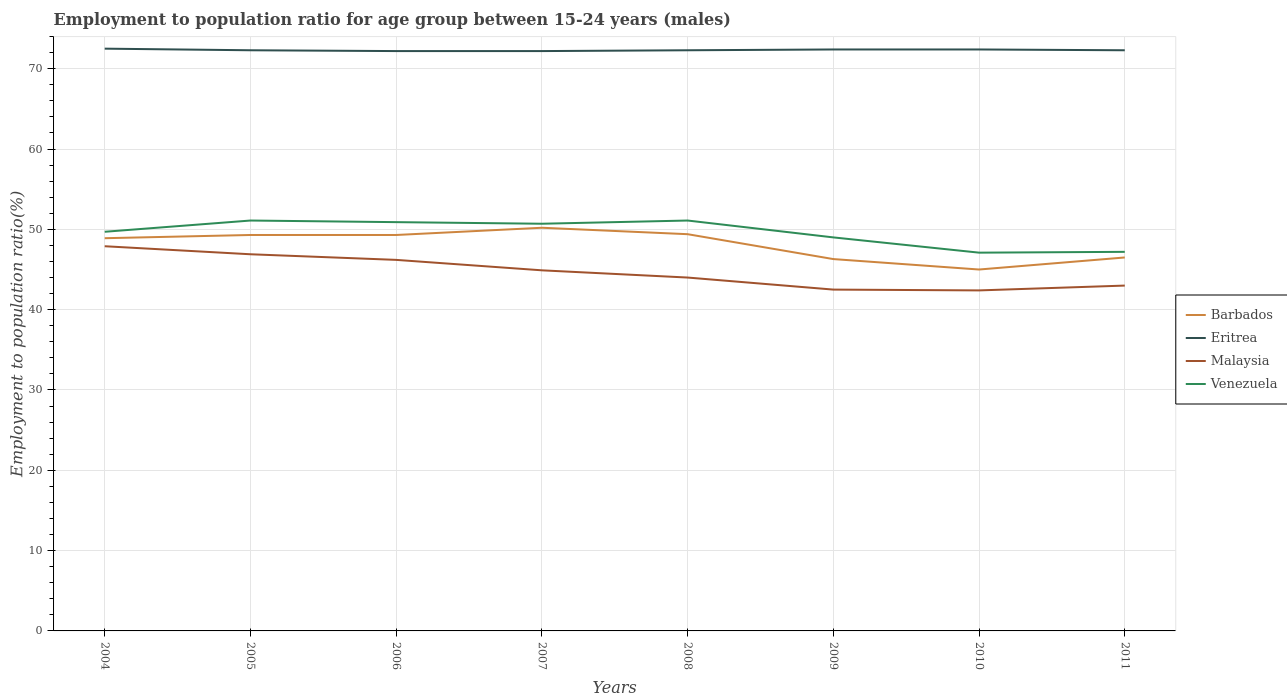Does the line corresponding to Eritrea intersect with the line corresponding to Barbados?
Provide a succinct answer. No. Is the number of lines equal to the number of legend labels?
Your response must be concise. Yes. Across all years, what is the maximum employment to population ratio in Malaysia?
Offer a terse response. 42.4. What is the total employment to population ratio in Eritrea in the graph?
Provide a short and direct response. 0.1. What is the difference between the highest and the second highest employment to population ratio in Barbados?
Your response must be concise. 5.2. What is the difference between the highest and the lowest employment to population ratio in Eritrea?
Offer a terse response. 3. Is the employment to population ratio in Barbados strictly greater than the employment to population ratio in Venezuela over the years?
Your response must be concise. Yes. How many lines are there?
Give a very brief answer. 4. How many years are there in the graph?
Your response must be concise. 8. What is the difference between two consecutive major ticks on the Y-axis?
Provide a succinct answer. 10. Does the graph contain grids?
Your answer should be compact. Yes. Where does the legend appear in the graph?
Your answer should be very brief. Center right. How are the legend labels stacked?
Give a very brief answer. Vertical. What is the title of the graph?
Make the answer very short. Employment to population ratio for age group between 15-24 years (males). What is the label or title of the X-axis?
Your answer should be compact. Years. What is the label or title of the Y-axis?
Offer a very short reply. Employment to population ratio(%). What is the Employment to population ratio(%) of Barbados in 2004?
Your answer should be very brief. 48.9. What is the Employment to population ratio(%) of Eritrea in 2004?
Provide a succinct answer. 72.5. What is the Employment to population ratio(%) in Malaysia in 2004?
Ensure brevity in your answer.  47.9. What is the Employment to population ratio(%) of Venezuela in 2004?
Provide a short and direct response. 49.7. What is the Employment to population ratio(%) of Barbados in 2005?
Offer a very short reply. 49.3. What is the Employment to population ratio(%) in Eritrea in 2005?
Give a very brief answer. 72.3. What is the Employment to population ratio(%) in Malaysia in 2005?
Give a very brief answer. 46.9. What is the Employment to population ratio(%) of Venezuela in 2005?
Your answer should be compact. 51.1. What is the Employment to population ratio(%) of Barbados in 2006?
Give a very brief answer. 49.3. What is the Employment to population ratio(%) of Eritrea in 2006?
Your answer should be very brief. 72.2. What is the Employment to population ratio(%) of Malaysia in 2006?
Give a very brief answer. 46.2. What is the Employment to population ratio(%) in Venezuela in 2006?
Your answer should be compact. 50.9. What is the Employment to population ratio(%) in Barbados in 2007?
Your answer should be very brief. 50.2. What is the Employment to population ratio(%) of Eritrea in 2007?
Make the answer very short. 72.2. What is the Employment to population ratio(%) of Malaysia in 2007?
Provide a short and direct response. 44.9. What is the Employment to population ratio(%) in Venezuela in 2007?
Provide a succinct answer. 50.7. What is the Employment to population ratio(%) in Barbados in 2008?
Offer a very short reply. 49.4. What is the Employment to population ratio(%) in Eritrea in 2008?
Give a very brief answer. 72.3. What is the Employment to population ratio(%) of Malaysia in 2008?
Offer a very short reply. 44. What is the Employment to population ratio(%) in Venezuela in 2008?
Provide a succinct answer. 51.1. What is the Employment to population ratio(%) of Barbados in 2009?
Make the answer very short. 46.3. What is the Employment to population ratio(%) of Eritrea in 2009?
Ensure brevity in your answer.  72.4. What is the Employment to population ratio(%) of Malaysia in 2009?
Provide a short and direct response. 42.5. What is the Employment to population ratio(%) in Barbados in 2010?
Offer a very short reply. 45. What is the Employment to population ratio(%) in Eritrea in 2010?
Offer a terse response. 72.4. What is the Employment to population ratio(%) in Malaysia in 2010?
Provide a short and direct response. 42.4. What is the Employment to population ratio(%) in Venezuela in 2010?
Make the answer very short. 47.1. What is the Employment to population ratio(%) of Barbados in 2011?
Offer a very short reply. 46.5. What is the Employment to population ratio(%) of Eritrea in 2011?
Make the answer very short. 72.3. What is the Employment to population ratio(%) in Venezuela in 2011?
Your answer should be very brief. 47.2. Across all years, what is the maximum Employment to population ratio(%) of Barbados?
Ensure brevity in your answer.  50.2. Across all years, what is the maximum Employment to population ratio(%) in Eritrea?
Provide a short and direct response. 72.5. Across all years, what is the maximum Employment to population ratio(%) of Malaysia?
Your answer should be very brief. 47.9. Across all years, what is the maximum Employment to population ratio(%) in Venezuela?
Make the answer very short. 51.1. Across all years, what is the minimum Employment to population ratio(%) of Eritrea?
Make the answer very short. 72.2. Across all years, what is the minimum Employment to population ratio(%) in Malaysia?
Provide a succinct answer. 42.4. Across all years, what is the minimum Employment to population ratio(%) of Venezuela?
Ensure brevity in your answer.  47.1. What is the total Employment to population ratio(%) in Barbados in the graph?
Provide a short and direct response. 384.9. What is the total Employment to population ratio(%) in Eritrea in the graph?
Make the answer very short. 578.6. What is the total Employment to population ratio(%) of Malaysia in the graph?
Keep it short and to the point. 357.8. What is the total Employment to population ratio(%) in Venezuela in the graph?
Keep it short and to the point. 396.8. What is the difference between the Employment to population ratio(%) of Barbados in 2004 and that in 2005?
Make the answer very short. -0.4. What is the difference between the Employment to population ratio(%) of Malaysia in 2004 and that in 2005?
Your answer should be compact. 1. What is the difference between the Employment to population ratio(%) of Eritrea in 2004 and that in 2006?
Provide a short and direct response. 0.3. What is the difference between the Employment to population ratio(%) in Malaysia in 2004 and that in 2006?
Your answer should be very brief. 1.7. What is the difference between the Employment to population ratio(%) in Barbados in 2004 and that in 2008?
Your response must be concise. -0.5. What is the difference between the Employment to population ratio(%) of Barbados in 2004 and that in 2009?
Ensure brevity in your answer.  2.6. What is the difference between the Employment to population ratio(%) in Venezuela in 2004 and that in 2009?
Give a very brief answer. 0.7. What is the difference between the Employment to population ratio(%) in Eritrea in 2004 and that in 2010?
Provide a succinct answer. 0.1. What is the difference between the Employment to population ratio(%) in Barbados in 2004 and that in 2011?
Provide a short and direct response. 2.4. What is the difference between the Employment to population ratio(%) in Eritrea in 2004 and that in 2011?
Your answer should be compact. 0.2. What is the difference between the Employment to population ratio(%) of Eritrea in 2005 and that in 2006?
Offer a terse response. 0.1. What is the difference between the Employment to population ratio(%) in Malaysia in 2005 and that in 2006?
Provide a succinct answer. 0.7. What is the difference between the Employment to population ratio(%) of Venezuela in 2005 and that in 2006?
Offer a very short reply. 0.2. What is the difference between the Employment to population ratio(%) in Barbados in 2005 and that in 2007?
Offer a terse response. -0.9. What is the difference between the Employment to population ratio(%) in Eritrea in 2005 and that in 2007?
Your answer should be compact. 0.1. What is the difference between the Employment to population ratio(%) in Malaysia in 2005 and that in 2007?
Give a very brief answer. 2. What is the difference between the Employment to population ratio(%) in Venezuela in 2005 and that in 2007?
Provide a short and direct response. 0.4. What is the difference between the Employment to population ratio(%) of Barbados in 2005 and that in 2008?
Make the answer very short. -0.1. What is the difference between the Employment to population ratio(%) in Eritrea in 2005 and that in 2008?
Your answer should be very brief. 0. What is the difference between the Employment to population ratio(%) of Malaysia in 2005 and that in 2008?
Keep it short and to the point. 2.9. What is the difference between the Employment to population ratio(%) in Barbados in 2005 and that in 2009?
Your answer should be very brief. 3. What is the difference between the Employment to population ratio(%) of Eritrea in 2005 and that in 2009?
Ensure brevity in your answer.  -0.1. What is the difference between the Employment to population ratio(%) of Malaysia in 2005 and that in 2009?
Your answer should be very brief. 4.4. What is the difference between the Employment to population ratio(%) in Barbados in 2005 and that in 2010?
Your answer should be very brief. 4.3. What is the difference between the Employment to population ratio(%) in Eritrea in 2005 and that in 2010?
Your answer should be very brief. -0.1. What is the difference between the Employment to population ratio(%) in Malaysia in 2005 and that in 2011?
Make the answer very short. 3.9. What is the difference between the Employment to population ratio(%) in Venezuela in 2005 and that in 2011?
Provide a succinct answer. 3.9. What is the difference between the Employment to population ratio(%) of Eritrea in 2006 and that in 2007?
Offer a terse response. 0. What is the difference between the Employment to population ratio(%) of Barbados in 2006 and that in 2008?
Your answer should be very brief. -0.1. What is the difference between the Employment to population ratio(%) in Venezuela in 2006 and that in 2008?
Your answer should be compact. -0.2. What is the difference between the Employment to population ratio(%) of Barbados in 2006 and that in 2009?
Make the answer very short. 3. What is the difference between the Employment to population ratio(%) in Malaysia in 2006 and that in 2009?
Ensure brevity in your answer.  3.7. What is the difference between the Employment to population ratio(%) in Barbados in 2006 and that in 2010?
Your answer should be very brief. 4.3. What is the difference between the Employment to population ratio(%) of Eritrea in 2006 and that in 2010?
Give a very brief answer. -0.2. What is the difference between the Employment to population ratio(%) in Malaysia in 2006 and that in 2010?
Make the answer very short. 3.8. What is the difference between the Employment to population ratio(%) in Venezuela in 2006 and that in 2010?
Give a very brief answer. 3.8. What is the difference between the Employment to population ratio(%) in Barbados in 2006 and that in 2011?
Your response must be concise. 2.8. What is the difference between the Employment to population ratio(%) in Eritrea in 2006 and that in 2011?
Your answer should be compact. -0.1. What is the difference between the Employment to population ratio(%) of Malaysia in 2006 and that in 2011?
Ensure brevity in your answer.  3.2. What is the difference between the Employment to population ratio(%) of Venezuela in 2006 and that in 2011?
Provide a short and direct response. 3.7. What is the difference between the Employment to population ratio(%) in Malaysia in 2007 and that in 2008?
Keep it short and to the point. 0.9. What is the difference between the Employment to population ratio(%) in Venezuela in 2007 and that in 2008?
Your answer should be very brief. -0.4. What is the difference between the Employment to population ratio(%) of Barbados in 2007 and that in 2009?
Offer a terse response. 3.9. What is the difference between the Employment to population ratio(%) in Malaysia in 2007 and that in 2009?
Offer a very short reply. 2.4. What is the difference between the Employment to population ratio(%) in Venezuela in 2007 and that in 2011?
Ensure brevity in your answer.  3.5. What is the difference between the Employment to population ratio(%) in Venezuela in 2008 and that in 2009?
Your answer should be compact. 2.1. What is the difference between the Employment to population ratio(%) in Barbados in 2008 and that in 2010?
Keep it short and to the point. 4.4. What is the difference between the Employment to population ratio(%) of Malaysia in 2008 and that in 2010?
Your answer should be compact. 1.6. What is the difference between the Employment to population ratio(%) of Venezuela in 2008 and that in 2010?
Your response must be concise. 4. What is the difference between the Employment to population ratio(%) in Barbados in 2008 and that in 2011?
Offer a very short reply. 2.9. What is the difference between the Employment to population ratio(%) in Eritrea in 2008 and that in 2011?
Make the answer very short. 0. What is the difference between the Employment to population ratio(%) of Barbados in 2009 and that in 2010?
Provide a succinct answer. 1.3. What is the difference between the Employment to population ratio(%) in Eritrea in 2009 and that in 2010?
Provide a short and direct response. 0. What is the difference between the Employment to population ratio(%) of Venezuela in 2009 and that in 2010?
Your answer should be very brief. 1.9. What is the difference between the Employment to population ratio(%) of Barbados in 2009 and that in 2011?
Your answer should be compact. -0.2. What is the difference between the Employment to population ratio(%) of Malaysia in 2009 and that in 2011?
Ensure brevity in your answer.  -0.5. What is the difference between the Employment to population ratio(%) of Venezuela in 2009 and that in 2011?
Your answer should be compact. 1.8. What is the difference between the Employment to population ratio(%) in Barbados in 2010 and that in 2011?
Make the answer very short. -1.5. What is the difference between the Employment to population ratio(%) in Venezuela in 2010 and that in 2011?
Provide a short and direct response. -0.1. What is the difference between the Employment to population ratio(%) in Barbados in 2004 and the Employment to population ratio(%) in Eritrea in 2005?
Keep it short and to the point. -23.4. What is the difference between the Employment to population ratio(%) in Barbados in 2004 and the Employment to population ratio(%) in Malaysia in 2005?
Your response must be concise. 2. What is the difference between the Employment to population ratio(%) of Eritrea in 2004 and the Employment to population ratio(%) of Malaysia in 2005?
Provide a short and direct response. 25.6. What is the difference between the Employment to population ratio(%) of Eritrea in 2004 and the Employment to population ratio(%) of Venezuela in 2005?
Your answer should be compact. 21.4. What is the difference between the Employment to population ratio(%) in Malaysia in 2004 and the Employment to population ratio(%) in Venezuela in 2005?
Give a very brief answer. -3.2. What is the difference between the Employment to population ratio(%) of Barbados in 2004 and the Employment to population ratio(%) of Eritrea in 2006?
Ensure brevity in your answer.  -23.3. What is the difference between the Employment to population ratio(%) of Barbados in 2004 and the Employment to population ratio(%) of Venezuela in 2006?
Make the answer very short. -2. What is the difference between the Employment to population ratio(%) of Eritrea in 2004 and the Employment to population ratio(%) of Malaysia in 2006?
Your answer should be very brief. 26.3. What is the difference between the Employment to population ratio(%) in Eritrea in 2004 and the Employment to population ratio(%) in Venezuela in 2006?
Make the answer very short. 21.6. What is the difference between the Employment to population ratio(%) in Barbados in 2004 and the Employment to population ratio(%) in Eritrea in 2007?
Your answer should be very brief. -23.3. What is the difference between the Employment to population ratio(%) in Eritrea in 2004 and the Employment to population ratio(%) in Malaysia in 2007?
Ensure brevity in your answer.  27.6. What is the difference between the Employment to population ratio(%) in Eritrea in 2004 and the Employment to population ratio(%) in Venezuela in 2007?
Ensure brevity in your answer.  21.8. What is the difference between the Employment to population ratio(%) of Barbados in 2004 and the Employment to population ratio(%) of Eritrea in 2008?
Ensure brevity in your answer.  -23.4. What is the difference between the Employment to population ratio(%) of Barbados in 2004 and the Employment to population ratio(%) of Venezuela in 2008?
Offer a terse response. -2.2. What is the difference between the Employment to population ratio(%) in Eritrea in 2004 and the Employment to population ratio(%) in Venezuela in 2008?
Offer a terse response. 21.4. What is the difference between the Employment to population ratio(%) of Barbados in 2004 and the Employment to population ratio(%) of Eritrea in 2009?
Provide a succinct answer. -23.5. What is the difference between the Employment to population ratio(%) of Barbados in 2004 and the Employment to population ratio(%) of Malaysia in 2009?
Offer a terse response. 6.4. What is the difference between the Employment to population ratio(%) in Eritrea in 2004 and the Employment to population ratio(%) in Malaysia in 2009?
Offer a very short reply. 30. What is the difference between the Employment to population ratio(%) in Malaysia in 2004 and the Employment to population ratio(%) in Venezuela in 2009?
Your answer should be compact. -1.1. What is the difference between the Employment to population ratio(%) in Barbados in 2004 and the Employment to population ratio(%) in Eritrea in 2010?
Make the answer very short. -23.5. What is the difference between the Employment to population ratio(%) in Barbados in 2004 and the Employment to population ratio(%) in Malaysia in 2010?
Your response must be concise. 6.5. What is the difference between the Employment to population ratio(%) in Eritrea in 2004 and the Employment to population ratio(%) in Malaysia in 2010?
Your answer should be compact. 30.1. What is the difference between the Employment to population ratio(%) of Eritrea in 2004 and the Employment to population ratio(%) of Venezuela in 2010?
Make the answer very short. 25.4. What is the difference between the Employment to population ratio(%) of Barbados in 2004 and the Employment to population ratio(%) of Eritrea in 2011?
Your response must be concise. -23.4. What is the difference between the Employment to population ratio(%) of Barbados in 2004 and the Employment to population ratio(%) of Malaysia in 2011?
Give a very brief answer. 5.9. What is the difference between the Employment to population ratio(%) of Eritrea in 2004 and the Employment to population ratio(%) of Malaysia in 2011?
Provide a succinct answer. 29.5. What is the difference between the Employment to population ratio(%) in Eritrea in 2004 and the Employment to population ratio(%) in Venezuela in 2011?
Your answer should be compact. 25.3. What is the difference between the Employment to population ratio(%) in Barbados in 2005 and the Employment to population ratio(%) in Eritrea in 2006?
Ensure brevity in your answer.  -22.9. What is the difference between the Employment to population ratio(%) of Barbados in 2005 and the Employment to population ratio(%) of Malaysia in 2006?
Provide a short and direct response. 3.1. What is the difference between the Employment to population ratio(%) of Eritrea in 2005 and the Employment to population ratio(%) of Malaysia in 2006?
Give a very brief answer. 26.1. What is the difference between the Employment to population ratio(%) in Eritrea in 2005 and the Employment to population ratio(%) in Venezuela in 2006?
Give a very brief answer. 21.4. What is the difference between the Employment to population ratio(%) in Barbados in 2005 and the Employment to population ratio(%) in Eritrea in 2007?
Ensure brevity in your answer.  -22.9. What is the difference between the Employment to population ratio(%) in Eritrea in 2005 and the Employment to population ratio(%) in Malaysia in 2007?
Ensure brevity in your answer.  27.4. What is the difference between the Employment to population ratio(%) in Eritrea in 2005 and the Employment to population ratio(%) in Venezuela in 2007?
Provide a succinct answer. 21.6. What is the difference between the Employment to population ratio(%) of Malaysia in 2005 and the Employment to population ratio(%) of Venezuela in 2007?
Your answer should be compact. -3.8. What is the difference between the Employment to population ratio(%) of Barbados in 2005 and the Employment to population ratio(%) of Eritrea in 2008?
Ensure brevity in your answer.  -23. What is the difference between the Employment to population ratio(%) in Barbados in 2005 and the Employment to population ratio(%) in Malaysia in 2008?
Make the answer very short. 5.3. What is the difference between the Employment to population ratio(%) in Barbados in 2005 and the Employment to population ratio(%) in Venezuela in 2008?
Give a very brief answer. -1.8. What is the difference between the Employment to population ratio(%) in Eritrea in 2005 and the Employment to population ratio(%) in Malaysia in 2008?
Ensure brevity in your answer.  28.3. What is the difference between the Employment to population ratio(%) of Eritrea in 2005 and the Employment to population ratio(%) of Venezuela in 2008?
Provide a succinct answer. 21.2. What is the difference between the Employment to population ratio(%) in Barbados in 2005 and the Employment to population ratio(%) in Eritrea in 2009?
Your response must be concise. -23.1. What is the difference between the Employment to population ratio(%) in Barbados in 2005 and the Employment to population ratio(%) in Venezuela in 2009?
Ensure brevity in your answer.  0.3. What is the difference between the Employment to population ratio(%) of Eritrea in 2005 and the Employment to population ratio(%) of Malaysia in 2009?
Ensure brevity in your answer.  29.8. What is the difference between the Employment to population ratio(%) in Eritrea in 2005 and the Employment to population ratio(%) in Venezuela in 2009?
Offer a terse response. 23.3. What is the difference between the Employment to population ratio(%) in Barbados in 2005 and the Employment to population ratio(%) in Eritrea in 2010?
Offer a terse response. -23.1. What is the difference between the Employment to population ratio(%) in Barbados in 2005 and the Employment to population ratio(%) in Malaysia in 2010?
Offer a very short reply. 6.9. What is the difference between the Employment to population ratio(%) of Eritrea in 2005 and the Employment to population ratio(%) of Malaysia in 2010?
Provide a short and direct response. 29.9. What is the difference between the Employment to population ratio(%) of Eritrea in 2005 and the Employment to population ratio(%) of Venezuela in 2010?
Give a very brief answer. 25.2. What is the difference between the Employment to population ratio(%) of Barbados in 2005 and the Employment to population ratio(%) of Venezuela in 2011?
Ensure brevity in your answer.  2.1. What is the difference between the Employment to population ratio(%) in Eritrea in 2005 and the Employment to population ratio(%) in Malaysia in 2011?
Provide a succinct answer. 29.3. What is the difference between the Employment to population ratio(%) in Eritrea in 2005 and the Employment to population ratio(%) in Venezuela in 2011?
Your answer should be very brief. 25.1. What is the difference between the Employment to population ratio(%) in Malaysia in 2005 and the Employment to population ratio(%) in Venezuela in 2011?
Ensure brevity in your answer.  -0.3. What is the difference between the Employment to population ratio(%) of Barbados in 2006 and the Employment to population ratio(%) of Eritrea in 2007?
Offer a terse response. -22.9. What is the difference between the Employment to population ratio(%) in Barbados in 2006 and the Employment to population ratio(%) in Malaysia in 2007?
Your answer should be compact. 4.4. What is the difference between the Employment to population ratio(%) in Barbados in 2006 and the Employment to population ratio(%) in Venezuela in 2007?
Provide a short and direct response. -1.4. What is the difference between the Employment to population ratio(%) in Eritrea in 2006 and the Employment to population ratio(%) in Malaysia in 2007?
Your response must be concise. 27.3. What is the difference between the Employment to population ratio(%) in Eritrea in 2006 and the Employment to population ratio(%) in Venezuela in 2007?
Offer a very short reply. 21.5. What is the difference between the Employment to population ratio(%) of Barbados in 2006 and the Employment to population ratio(%) of Malaysia in 2008?
Your response must be concise. 5.3. What is the difference between the Employment to population ratio(%) in Eritrea in 2006 and the Employment to population ratio(%) in Malaysia in 2008?
Keep it short and to the point. 28.2. What is the difference between the Employment to population ratio(%) in Eritrea in 2006 and the Employment to population ratio(%) in Venezuela in 2008?
Make the answer very short. 21.1. What is the difference between the Employment to population ratio(%) in Barbados in 2006 and the Employment to population ratio(%) in Eritrea in 2009?
Your response must be concise. -23.1. What is the difference between the Employment to population ratio(%) in Barbados in 2006 and the Employment to population ratio(%) in Malaysia in 2009?
Offer a very short reply. 6.8. What is the difference between the Employment to population ratio(%) in Barbados in 2006 and the Employment to population ratio(%) in Venezuela in 2009?
Provide a succinct answer. 0.3. What is the difference between the Employment to population ratio(%) of Eritrea in 2006 and the Employment to population ratio(%) of Malaysia in 2009?
Keep it short and to the point. 29.7. What is the difference between the Employment to population ratio(%) in Eritrea in 2006 and the Employment to population ratio(%) in Venezuela in 2009?
Offer a very short reply. 23.2. What is the difference between the Employment to population ratio(%) in Barbados in 2006 and the Employment to population ratio(%) in Eritrea in 2010?
Offer a terse response. -23.1. What is the difference between the Employment to population ratio(%) of Barbados in 2006 and the Employment to population ratio(%) of Malaysia in 2010?
Provide a succinct answer. 6.9. What is the difference between the Employment to population ratio(%) in Barbados in 2006 and the Employment to population ratio(%) in Venezuela in 2010?
Provide a short and direct response. 2.2. What is the difference between the Employment to population ratio(%) in Eritrea in 2006 and the Employment to population ratio(%) in Malaysia in 2010?
Offer a very short reply. 29.8. What is the difference between the Employment to population ratio(%) in Eritrea in 2006 and the Employment to population ratio(%) in Venezuela in 2010?
Your answer should be very brief. 25.1. What is the difference between the Employment to population ratio(%) in Malaysia in 2006 and the Employment to population ratio(%) in Venezuela in 2010?
Your answer should be compact. -0.9. What is the difference between the Employment to population ratio(%) in Eritrea in 2006 and the Employment to population ratio(%) in Malaysia in 2011?
Ensure brevity in your answer.  29.2. What is the difference between the Employment to population ratio(%) in Barbados in 2007 and the Employment to population ratio(%) in Eritrea in 2008?
Give a very brief answer. -22.1. What is the difference between the Employment to population ratio(%) in Barbados in 2007 and the Employment to population ratio(%) in Malaysia in 2008?
Keep it short and to the point. 6.2. What is the difference between the Employment to population ratio(%) of Barbados in 2007 and the Employment to population ratio(%) of Venezuela in 2008?
Your answer should be very brief. -0.9. What is the difference between the Employment to population ratio(%) of Eritrea in 2007 and the Employment to population ratio(%) of Malaysia in 2008?
Offer a terse response. 28.2. What is the difference between the Employment to population ratio(%) in Eritrea in 2007 and the Employment to population ratio(%) in Venezuela in 2008?
Provide a succinct answer. 21.1. What is the difference between the Employment to population ratio(%) in Malaysia in 2007 and the Employment to population ratio(%) in Venezuela in 2008?
Your answer should be very brief. -6.2. What is the difference between the Employment to population ratio(%) of Barbados in 2007 and the Employment to population ratio(%) of Eritrea in 2009?
Ensure brevity in your answer.  -22.2. What is the difference between the Employment to population ratio(%) in Barbados in 2007 and the Employment to population ratio(%) in Malaysia in 2009?
Offer a terse response. 7.7. What is the difference between the Employment to population ratio(%) in Eritrea in 2007 and the Employment to population ratio(%) in Malaysia in 2009?
Keep it short and to the point. 29.7. What is the difference between the Employment to population ratio(%) in Eritrea in 2007 and the Employment to population ratio(%) in Venezuela in 2009?
Provide a succinct answer. 23.2. What is the difference between the Employment to population ratio(%) of Barbados in 2007 and the Employment to population ratio(%) of Eritrea in 2010?
Your answer should be very brief. -22.2. What is the difference between the Employment to population ratio(%) of Barbados in 2007 and the Employment to population ratio(%) of Malaysia in 2010?
Your answer should be compact. 7.8. What is the difference between the Employment to population ratio(%) in Barbados in 2007 and the Employment to population ratio(%) in Venezuela in 2010?
Offer a terse response. 3.1. What is the difference between the Employment to population ratio(%) of Eritrea in 2007 and the Employment to population ratio(%) of Malaysia in 2010?
Your answer should be very brief. 29.8. What is the difference between the Employment to population ratio(%) of Eritrea in 2007 and the Employment to population ratio(%) of Venezuela in 2010?
Offer a very short reply. 25.1. What is the difference between the Employment to population ratio(%) in Malaysia in 2007 and the Employment to population ratio(%) in Venezuela in 2010?
Make the answer very short. -2.2. What is the difference between the Employment to population ratio(%) of Barbados in 2007 and the Employment to population ratio(%) of Eritrea in 2011?
Offer a very short reply. -22.1. What is the difference between the Employment to population ratio(%) in Eritrea in 2007 and the Employment to population ratio(%) in Malaysia in 2011?
Provide a short and direct response. 29.2. What is the difference between the Employment to population ratio(%) of Eritrea in 2007 and the Employment to population ratio(%) of Venezuela in 2011?
Your answer should be very brief. 25. What is the difference between the Employment to population ratio(%) of Malaysia in 2007 and the Employment to population ratio(%) of Venezuela in 2011?
Your answer should be very brief. -2.3. What is the difference between the Employment to population ratio(%) in Barbados in 2008 and the Employment to population ratio(%) in Eritrea in 2009?
Provide a short and direct response. -23. What is the difference between the Employment to population ratio(%) of Barbados in 2008 and the Employment to population ratio(%) of Venezuela in 2009?
Your answer should be very brief. 0.4. What is the difference between the Employment to population ratio(%) in Eritrea in 2008 and the Employment to population ratio(%) in Malaysia in 2009?
Provide a short and direct response. 29.8. What is the difference between the Employment to population ratio(%) of Eritrea in 2008 and the Employment to population ratio(%) of Venezuela in 2009?
Give a very brief answer. 23.3. What is the difference between the Employment to population ratio(%) in Malaysia in 2008 and the Employment to population ratio(%) in Venezuela in 2009?
Your answer should be compact. -5. What is the difference between the Employment to population ratio(%) of Barbados in 2008 and the Employment to population ratio(%) of Eritrea in 2010?
Offer a very short reply. -23. What is the difference between the Employment to population ratio(%) of Eritrea in 2008 and the Employment to population ratio(%) of Malaysia in 2010?
Ensure brevity in your answer.  29.9. What is the difference between the Employment to population ratio(%) of Eritrea in 2008 and the Employment to population ratio(%) of Venezuela in 2010?
Provide a succinct answer. 25.2. What is the difference between the Employment to population ratio(%) in Barbados in 2008 and the Employment to population ratio(%) in Eritrea in 2011?
Your response must be concise. -22.9. What is the difference between the Employment to population ratio(%) in Barbados in 2008 and the Employment to population ratio(%) in Malaysia in 2011?
Make the answer very short. 6.4. What is the difference between the Employment to population ratio(%) of Barbados in 2008 and the Employment to population ratio(%) of Venezuela in 2011?
Your answer should be compact. 2.2. What is the difference between the Employment to population ratio(%) of Eritrea in 2008 and the Employment to population ratio(%) of Malaysia in 2011?
Your answer should be compact. 29.3. What is the difference between the Employment to population ratio(%) of Eritrea in 2008 and the Employment to population ratio(%) of Venezuela in 2011?
Provide a short and direct response. 25.1. What is the difference between the Employment to population ratio(%) in Barbados in 2009 and the Employment to population ratio(%) in Eritrea in 2010?
Your response must be concise. -26.1. What is the difference between the Employment to population ratio(%) in Barbados in 2009 and the Employment to population ratio(%) in Malaysia in 2010?
Provide a succinct answer. 3.9. What is the difference between the Employment to population ratio(%) of Eritrea in 2009 and the Employment to population ratio(%) of Venezuela in 2010?
Provide a succinct answer. 25.3. What is the difference between the Employment to population ratio(%) in Malaysia in 2009 and the Employment to population ratio(%) in Venezuela in 2010?
Your answer should be very brief. -4.6. What is the difference between the Employment to population ratio(%) in Barbados in 2009 and the Employment to population ratio(%) in Eritrea in 2011?
Your answer should be compact. -26. What is the difference between the Employment to population ratio(%) in Barbados in 2009 and the Employment to population ratio(%) in Malaysia in 2011?
Ensure brevity in your answer.  3.3. What is the difference between the Employment to population ratio(%) of Barbados in 2009 and the Employment to population ratio(%) of Venezuela in 2011?
Make the answer very short. -0.9. What is the difference between the Employment to population ratio(%) in Eritrea in 2009 and the Employment to population ratio(%) in Malaysia in 2011?
Your answer should be very brief. 29.4. What is the difference between the Employment to population ratio(%) of Eritrea in 2009 and the Employment to population ratio(%) of Venezuela in 2011?
Your answer should be compact. 25.2. What is the difference between the Employment to population ratio(%) in Malaysia in 2009 and the Employment to population ratio(%) in Venezuela in 2011?
Your answer should be compact. -4.7. What is the difference between the Employment to population ratio(%) in Barbados in 2010 and the Employment to population ratio(%) in Eritrea in 2011?
Offer a very short reply. -27.3. What is the difference between the Employment to population ratio(%) in Eritrea in 2010 and the Employment to population ratio(%) in Malaysia in 2011?
Your response must be concise. 29.4. What is the difference between the Employment to population ratio(%) in Eritrea in 2010 and the Employment to population ratio(%) in Venezuela in 2011?
Your response must be concise. 25.2. What is the average Employment to population ratio(%) of Barbados per year?
Keep it short and to the point. 48.11. What is the average Employment to population ratio(%) of Eritrea per year?
Keep it short and to the point. 72.33. What is the average Employment to population ratio(%) in Malaysia per year?
Offer a very short reply. 44.73. What is the average Employment to population ratio(%) in Venezuela per year?
Your response must be concise. 49.6. In the year 2004, what is the difference between the Employment to population ratio(%) of Barbados and Employment to population ratio(%) of Eritrea?
Your answer should be very brief. -23.6. In the year 2004, what is the difference between the Employment to population ratio(%) of Barbados and Employment to population ratio(%) of Venezuela?
Ensure brevity in your answer.  -0.8. In the year 2004, what is the difference between the Employment to population ratio(%) of Eritrea and Employment to population ratio(%) of Malaysia?
Give a very brief answer. 24.6. In the year 2004, what is the difference between the Employment to population ratio(%) in Eritrea and Employment to population ratio(%) in Venezuela?
Keep it short and to the point. 22.8. In the year 2004, what is the difference between the Employment to population ratio(%) of Malaysia and Employment to population ratio(%) of Venezuela?
Ensure brevity in your answer.  -1.8. In the year 2005, what is the difference between the Employment to population ratio(%) of Eritrea and Employment to population ratio(%) of Malaysia?
Offer a terse response. 25.4. In the year 2005, what is the difference between the Employment to population ratio(%) of Eritrea and Employment to population ratio(%) of Venezuela?
Your answer should be compact. 21.2. In the year 2006, what is the difference between the Employment to population ratio(%) in Barbados and Employment to population ratio(%) in Eritrea?
Ensure brevity in your answer.  -22.9. In the year 2006, what is the difference between the Employment to population ratio(%) of Barbados and Employment to population ratio(%) of Malaysia?
Your answer should be very brief. 3.1. In the year 2006, what is the difference between the Employment to population ratio(%) of Eritrea and Employment to population ratio(%) of Malaysia?
Offer a very short reply. 26. In the year 2006, what is the difference between the Employment to population ratio(%) of Eritrea and Employment to population ratio(%) of Venezuela?
Give a very brief answer. 21.3. In the year 2006, what is the difference between the Employment to population ratio(%) in Malaysia and Employment to population ratio(%) in Venezuela?
Offer a very short reply. -4.7. In the year 2007, what is the difference between the Employment to population ratio(%) of Barbados and Employment to population ratio(%) of Eritrea?
Give a very brief answer. -22. In the year 2007, what is the difference between the Employment to population ratio(%) in Eritrea and Employment to population ratio(%) in Malaysia?
Offer a very short reply. 27.3. In the year 2007, what is the difference between the Employment to population ratio(%) in Eritrea and Employment to population ratio(%) in Venezuela?
Provide a short and direct response. 21.5. In the year 2007, what is the difference between the Employment to population ratio(%) of Malaysia and Employment to population ratio(%) of Venezuela?
Offer a very short reply. -5.8. In the year 2008, what is the difference between the Employment to population ratio(%) of Barbados and Employment to population ratio(%) of Eritrea?
Make the answer very short. -22.9. In the year 2008, what is the difference between the Employment to population ratio(%) in Eritrea and Employment to population ratio(%) in Malaysia?
Your answer should be very brief. 28.3. In the year 2008, what is the difference between the Employment to population ratio(%) of Eritrea and Employment to population ratio(%) of Venezuela?
Your response must be concise. 21.2. In the year 2009, what is the difference between the Employment to population ratio(%) of Barbados and Employment to population ratio(%) of Eritrea?
Keep it short and to the point. -26.1. In the year 2009, what is the difference between the Employment to population ratio(%) of Barbados and Employment to population ratio(%) of Malaysia?
Provide a succinct answer. 3.8. In the year 2009, what is the difference between the Employment to population ratio(%) in Eritrea and Employment to population ratio(%) in Malaysia?
Keep it short and to the point. 29.9. In the year 2009, what is the difference between the Employment to population ratio(%) of Eritrea and Employment to population ratio(%) of Venezuela?
Keep it short and to the point. 23.4. In the year 2010, what is the difference between the Employment to population ratio(%) in Barbados and Employment to population ratio(%) in Eritrea?
Give a very brief answer. -27.4. In the year 2010, what is the difference between the Employment to population ratio(%) in Barbados and Employment to population ratio(%) in Malaysia?
Provide a short and direct response. 2.6. In the year 2010, what is the difference between the Employment to population ratio(%) in Barbados and Employment to population ratio(%) in Venezuela?
Your response must be concise. -2.1. In the year 2010, what is the difference between the Employment to population ratio(%) of Eritrea and Employment to population ratio(%) of Malaysia?
Ensure brevity in your answer.  30. In the year 2010, what is the difference between the Employment to population ratio(%) in Eritrea and Employment to population ratio(%) in Venezuela?
Your response must be concise. 25.3. In the year 2011, what is the difference between the Employment to population ratio(%) in Barbados and Employment to population ratio(%) in Eritrea?
Offer a very short reply. -25.8. In the year 2011, what is the difference between the Employment to population ratio(%) of Barbados and Employment to population ratio(%) of Malaysia?
Provide a succinct answer. 3.5. In the year 2011, what is the difference between the Employment to population ratio(%) in Eritrea and Employment to population ratio(%) in Malaysia?
Make the answer very short. 29.3. In the year 2011, what is the difference between the Employment to population ratio(%) of Eritrea and Employment to population ratio(%) of Venezuela?
Your answer should be compact. 25.1. In the year 2011, what is the difference between the Employment to population ratio(%) in Malaysia and Employment to population ratio(%) in Venezuela?
Your response must be concise. -4.2. What is the ratio of the Employment to population ratio(%) in Malaysia in 2004 to that in 2005?
Keep it short and to the point. 1.02. What is the ratio of the Employment to population ratio(%) of Venezuela in 2004 to that in 2005?
Provide a succinct answer. 0.97. What is the ratio of the Employment to population ratio(%) in Eritrea in 2004 to that in 2006?
Your answer should be very brief. 1. What is the ratio of the Employment to population ratio(%) of Malaysia in 2004 to that in 2006?
Ensure brevity in your answer.  1.04. What is the ratio of the Employment to population ratio(%) in Venezuela in 2004 to that in 2006?
Keep it short and to the point. 0.98. What is the ratio of the Employment to population ratio(%) of Barbados in 2004 to that in 2007?
Your response must be concise. 0.97. What is the ratio of the Employment to population ratio(%) in Eritrea in 2004 to that in 2007?
Make the answer very short. 1. What is the ratio of the Employment to population ratio(%) of Malaysia in 2004 to that in 2007?
Offer a very short reply. 1.07. What is the ratio of the Employment to population ratio(%) in Venezuela in 2004 to that in 2007?
Offer a terse response. 0.98. What is the ratio of the Employment to population ratio(%) of Barbados in 2004 to that in 2008?
Offer a very short reply. 0.99. What is the ratio of the Employment to population ratio(%) of Eritrea in 2004 to that in 2008?
Your answer should be compact. 1. What is the ratio of the Employment to population ratio(%) of Malaysia in 2004 to that in 2008?
Provide a short and direct response. 1.09. What is the ratio of the Employment to population ratio(%) in Venezuela in 2004 to that in 2008?
Give a very brief answer. 0.97. What is the ratio of the Employment to population ratio(%) of Barbados in 2004 to that in 2009?
Keep it short and to the point. 1.06. What is the ratio of the Employment to population ratio(%) in Malaysia in 2004 to that in 2009?
Make the answer very short. 1.13. What is the ratio of the Employment to population ratio(%) in Venezuela in 2004 to that in 2009?
Give a very brief answer. 1.01. What is the ratio of the Employment to population ratio(%) of Barbados in 2004 to that in 2010?
Ensure brevity in your answer.  1.09. What is the ratio of the Employment to population ratio(%) of Eritrea in 2004 to that in 2010?
Keep it short and to the point. 1. What is the ratio of the Employment to population ratio(%) in Malaysia in 2004 to that in 2010?
Keep it short and to the point. 1.13. What is the ratio of the Employment to population ratio(%) in Venezuela in 2004 to that in 2010?
Your response must be concise. 1.06. What is the ratio of the Employment to population ratio(%) of Barbados in 2004 to that in 2011?
Provide a short and direct response. 1.05. What is the ratio of the Employment to population ratio(%) in Eritrea in 2004 to that in 2011?
Keep it short and to the point. 1. What is the ratio of the Employment to population ratio(%) in Malaysia in 2004 to that in 2011?
Keep it short and to the point. 1.11. What is the ratio of the Employment to population ratio(%) of Venezuela in 2004 to that in 2011?
Your answer should be very brief. 1.05. What is the ratio of the Employment to population ratio(%) in Eritrea in 2005 to that in 2006?
Keep it short and to the point. 1. What is the ratio of the Employment to population ratio(%) of Malaysia in 2005 to that in 2006?
Provide a succinct answer. 1.02. What is the ratio of the Employment to population ratio(%) of Barbados in 2005 to that in 2007?
Ensure brevity in your answer.  0.98. What is the ratio of the Employment to population ratio(%) in Eritrea in 2005 to that in 2007?
Keep it short and to the point. 1. What is the ratio of the Employment to population ratio(%) of Malaysia in 2005 to that in 2007?
Offer a terse response. 1.04. What is the ratio of the Employment to population ratio(%) in Venezuela in 2005 to that in 2007?
Your answer should be very brief. 1.01. What is the ratio of the Employment to population ratio(%) in Barbados in 2005 to that in 2008?
Your answer should be compact. 1. What is the ratio of the Employment to population ratio(%) in Malaysia in 2005 to that in 2008?
Keep it short and to the point. 1.07. What is the ratio of the Employment to population ratio(%) in Barbados in 2005 to that in 2009?
Provide a short and direct response. 1.06. What is the ratio of the Employment to population ratio(%) of Malaysia in 2005 to that in 2009?
Ensure brevity in your answer.  1.1. What is the ratio of the Employment to population ratio(%) in Venezuela in 2005 to that in 2009?
Your answer should be very brief. 1.04. What is the ratio of the Employment to population ratio(%) in Barbados in 2005 to that in 2010?
Your answer should be compact. 1.1. What is the ratio of the Employment to population ratio(%) in Malaysia in 2005 to that in 2010?
Your answer should be very brief. 1.11. What is the ratio of the Employment to population ratio(%) of Venezuela in 2005 to that in 2010?
Offer a terse response. 1.08. What is the ratio of the Employment to population ratio(%) in Barbados in 2005 to that in 2011?
Your response must be concise. 1.06. What is the ratio of the Employment to population ratio(%) of Malaysia in 2005 to that in 2011?
Ensure brevity in your answer.  1.09. What is the ratio of the Employment to population ratio(%) of Venezuela in 2005 to that in 2011?
Your answer should be compact. 1.08. What is the ratio of the Employment to population ratio(%) in Barbados in 2006 to that in 2007?
Give a very brief answer. 0.98. What is the ratio of the Employment to population ratio(%) of Malaysia in 2006 to that in 2007?
Ensure brevity in your answer.  1.03. What is the ratio of the Employment to population ratio(%) of Venezuela in 2006 to that in 2007?
Keep it short and to the point. 1. What is the ratio of the Employment to population ratio(%) of Barbados in 2006 to that in 2008?
Provide a succinct answer. 1. What is the ratio of the Employment to population ratio(%) in Eritrea in 2006 to that in 2008?
Keep it short and to the point. 1. What is the ratio of the Employment to population ratio(%) in Malaysia in 2006 to that in 2008?
Give a very brief answer. 1.05. What is the ratio of the Employment to population ratio(%) in Venezuela in 2006 to that in 2008?
Your answer should be compact. 1. What is the ratio of the Employment to population ratio(%) of Barbados in 2006 to that in 2009?
Make the answer very short. 1.06. What is the ratio of the Employment to population ratio(%) of Eritrea in 2006 to that in 2009?
Keep it short and to the point. 1. What is the ratio of the Employment to population ratio(%) in Malaysia in 2006 to that in 2009?
Offer a very short reply. 1.09. What is the ratio of the Employment to population ratio(%) of Venezuela in 2006 to that in 2009?
Make the answer very short. 1.04. What is the ratio of the Employment to population ratio(%) of Barbados in 2006 to that in 2010?
Provide a short and direct response. 1.1. What is the ratio of the Employment to population ratio(%) of Eritrea in 2006 to that in 2010?
Your answer should be compact. 1. What is the ratio of the Employment to population ratio(%) in Malaysia in 2006 to that in 2010?
Offer a terse response. 1.09. What is the ratio of the Employment to population ratio(%) in Venezuela in 2006 to that in 2010?
Offer a very short reply. 1.08. What is the ratio of the Employment to population ratio(%) in Barbados in 2006 to that in 2011?
Offer a terse response. 1.06. What is the ratio of the Employment to population ratio(%) of Malaysia in 2006 to that in 2011?
Your answer should be very brief. 1.07. What is the ratio of the Employment to population ratio(%) of Venezuela in 2006 to that in 2011?
Provide a short and direct response. 1.08. What is the ratio of the Employment to population ratio(%) of Barbados in 2007 to that in 2008?
Offer a terse response. 1.02. What is the ratio of the Employment to population ratio(%) in Eritrea in 2007 to that in 2008?
Ensure brevity in your answer.  1. What is the ratio of the Employment to population ratio(%) in Malaysia in 2007 to that in 2008?
Make the answer very short. 1.02. What is the ratio of the Employment to population ratio(%) of Barbados in 2007 to that in 2009?
Offer a very short reply. 1.08. What is the ratio of the Employment to population ratio(%) of Malaysia in 2007 to that in 2009?
Provide a short and direct response. 1.06. What is the ratio of the Employment to population ratio(%) of Venezuela in 2007 to that in 2009?
Ensure brevity in your answer.  1.03. What is the ratio of the Employment to population ratio(%) of Barbados in 2007 to that in 2010?
Ensure brevity in your answer.  1.12. What is the ratio of the Employment to population ratio(%) in Malaysia in 2007 to that in 2010?
Provide a succinct answer. 1.06. What is the ratio of the Employment to population ratio(%) in Venezuela in 2007 to that in 2010?
Give a very brief answer. 1.08. What is the ratio of the Employment to population ratio(%) in Barbados in 2007 to that in 2011?
Offer a very short reply. 1.08. What is the ratio of the Employment to population ratio(%) of Malaysia in 2007 to that in 2011?
Offer a terse response. 1.04. What is the ratio of the Employment to population ratio(%) in Venezuela in 2007 to that in 2011?
Offer a terse response. 1.07. What is the ratio of the Employment to population ratio(%) in Barbados in 2008 to that in 2009?
Provide a short and direct response. 1.07. What is the ratio of the Employment to population ratio(%) of Eritrea in 2008 to that in 2009?
Offer a terse response. 1. What is the ratio of the Employment to population ratio(%) of Malaysia in 2008 to that in 2009?
Make the answer very short. 1.04. What is the ratio of the Employment to population ratio(%) of Venezuela in 2008 to that in 2009?
Offer a terse response. 1.04. What is the ratio of the Employment to population ratio(%) of Barbados in 2008 to that in 2010?
Offer a very short reply. 1.1. What is the ratio of the Employment to population ratio(%) of Malaysia in 2008 to that in 2010?
Your response must be concise. 1.04. What is the ratio of the Employment to population ratio(%) in Venezuela in 2008 to that in 2010?
Make the answer very short. 1.08. What is the ratio of the Employment to population ratio(%) of Barbados in 2008 to that in 2011?
Make the answer very short. 1.06. What is the ratio of the Employment to population ratio(%) of Malaysia in 2008 to that in 2011?
Offer a terse response. 1.02. What is the ratio of the Employment to population ratio(%) of Venezuela in 2008 to that in 2011?
Keep it short and to the point. 1.08. What is the ratio of the Employment to population ratio(%) of Barbados in 2009 to that in 2010?
Your response must be concise. 1.03. What is the ratio of the Employment to population ratio(%) in Malaysia in 2009 to that in 2010?
Keep it short and to the point. 1. What is the ratio of the Employment to population ratio(%) in Venezuela in 2009 to that in 2010?
Your response must be concise. 1.04. What is the ratio of the Employment to population ratio(%) of Malaysia in 2009 to that in 2011?
Make the answer very short. 0.99. What is the ratio of the Employment to population ratio(%) of Venezuela in 2009 to that in 2011?
Provide a succinct answer. 1.04. What is the ratio of the Employment to population ratio(%) of Eritrea in 2010 to that in 2011?
Ensure brevity in your answer.  1. What is the ratio of the Employment to population ratio(%) in Malaysia in 2010 to that in 2011?
Offer a very short reply. 0.99. What is the difference between the highest and the second highest Employment to population ratio(%) in Barbados?
Provide a short and direct response. 0.8. What is the difference between the highest and the second highest Employment to population ratio(%) in Venezuela?
Your response must be concise. 0. What is the difference between the highest and the lowest Employment to population ratio(%) of Malaysia?
Your response must be concise. 5.5. 